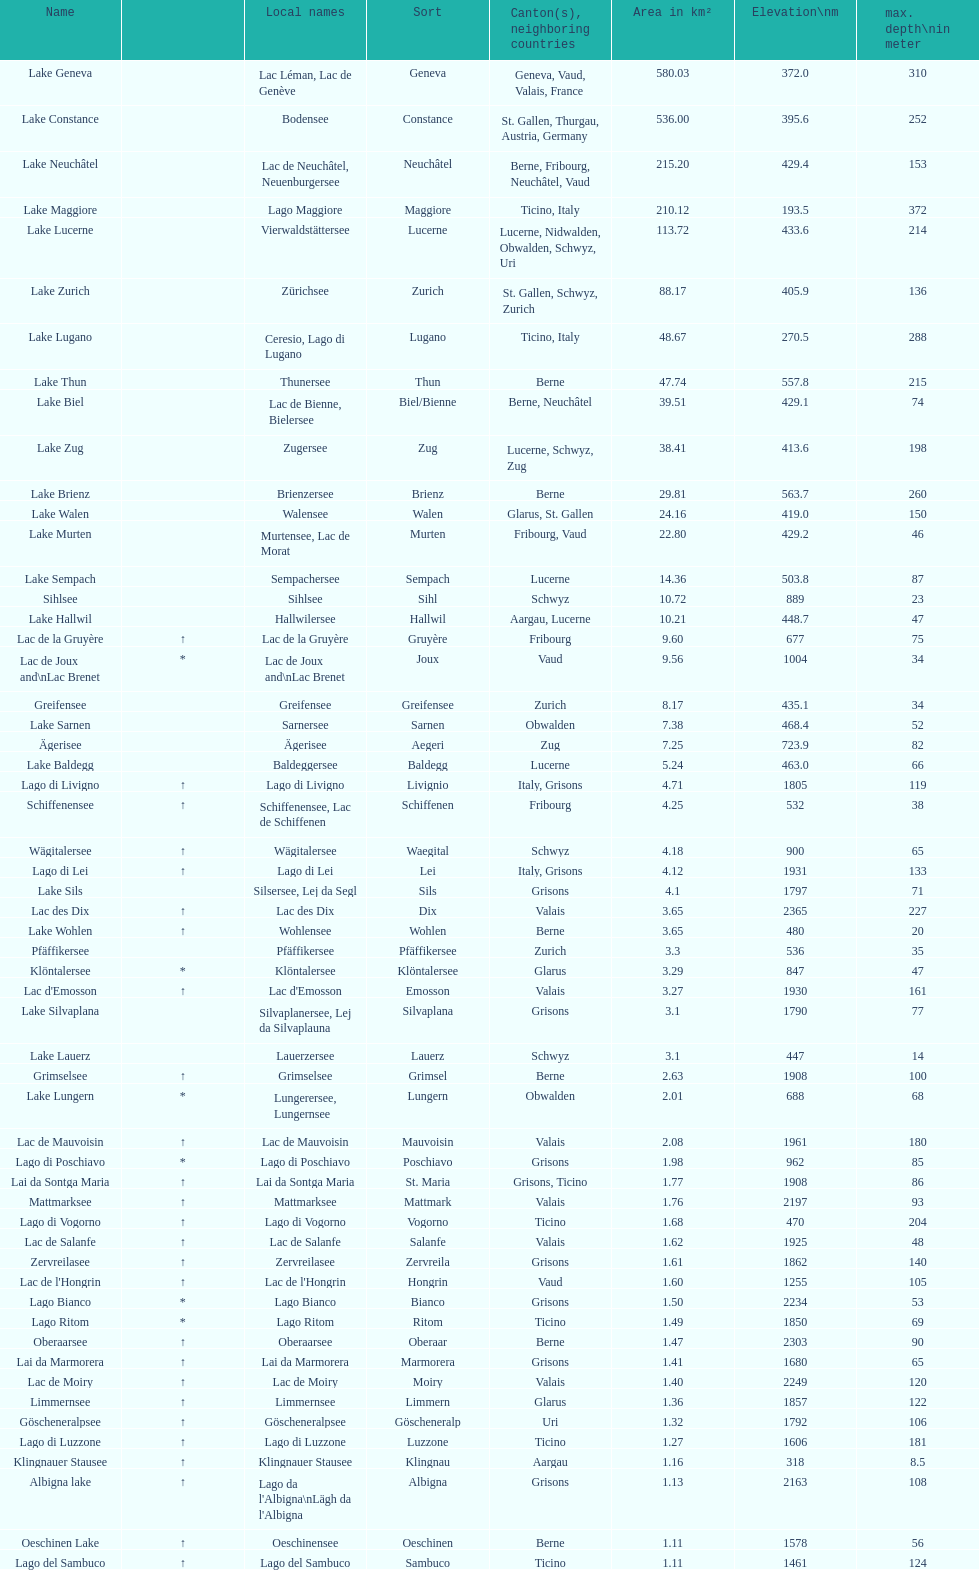I'm looking to parse the entire table for insights. Could you assist me with that? {'header': ['Name', '', 'Local names', 'Sort', 'Canton(s), neighboring countries', 'Area in km²', 'Elevation\\nm', 'max. depth\\nin meter'], 'rows': [['Lake Geneva', '', 'Lac Léman, Lac de Genève', 'Geneva', 'Geneva, Vaud, Valais, France', '580.03', '372.0', '310'], ['Lake Constance', '', 'Bodensee', 'Constance', 'St. Gallen, Thurgau, Austria, Germany', '536.00', '395.6', '252'], ['Lake Neuchâtel', '', 'Lac de Neuchâtel, Neuenburgersee', 'Neuchâtel', 'Berne, Fribourg, Neuchâtel, Vaud', '215.20', '429.4', '153'], ['Lake Maggiore', '', 'Lago Maggiore', 'Maggiore', 'Ticino, Italy', '210.12', '193.5', '372'], ['Lake Lucerne', '', 'Vierwaldstättersee', 'Lucerne', 'Lucerne, Nidwalden, Obwalden, Schwyz, Uri', '113.72', '433.6', '214'], ['Lake Zurich', '', 'Zürichsee', 'Zurich', 'St. Gallen, Schwyz, Zurich', '88.17', '405.9', '136'], ['Lake Lugano', '', 'Ceresio, Lago di Lugano', 'Lugano', 'Ticino, Italy', '48.67', '270.5', '288'], ['Lake Thun', '', 'Thunersee', 'Thun', 'Berne', '47.74', '557.8', '215'], ['Lake Biel', '', 'Lac de Bienne, Bielersee', 'Biel/Bienne', 'Berne, Neuchâtel', '39.51', '429.1', '74'], ['Lake Zug', '', 'Zugersee', 'Zug', 'Lucerne, Schwyz, Zug', '38.41', '413.6', '198'], ['Lake Brienz', '', 'Brienzersee', 'Brienz', 'Berne', '29.81', '563.7', '260'], ['Lake Walen', '', 'Walensee', 'Walen', 'Glarus, St. Gallen', '24.16', '419.0', '150'], ['Lake Murten', '', 'Murtensee, Lac de Morat', 'Murten', 'Fribourg, Vaud', '22.80', '429.2', '46'], ['Lake Sempach', '', 'Sempachersee', 'Sempach', 'Lucerne', '14.36', '503.8', '87'], ['Sihlsee', '', 'Sihlsee', 'Sihl', 'Schwyz', '10.72', '889', '23'], ['Lake Hallwil', '', 'Hallwilersee', 'Hallwil', 'Aargau, Lucerne', '10.21', '448.7', '47'], ['Lac de la Gruyère', '↑', 'Lac de la Gruyère', 'Gruyère', 'Fribourg', '9.60', '677', '75'], ['Lac de Joux and\\nLac Brenet', '*', 'Lac de Joux and\\nLac Brenet', 'Joux', 'Vaud', '9.56', '1004', '34'], ['Greifensee', '', 'Greifensee', 'Greifensee', 'Zurich', '8.17', '435.1', '34'], ['Lake Sarnen', '', 'Sarnersee', 'Sarnen', 'Obwalden', '7.38', '468.4', '52'], ['Ägerisee', '', 'Ägerisee', 'Aegeri', 'Zug', '7.25', '723.9', '82'], ['Lake Baldegg', '', 'Baldeggersee', 'Baldegg', 'Lucerne', '5.24', '463.0', '66'], ['Lago di Livigno', '↑', 'Lago di Livigno', 'Livignio', 'Italy, Grisons', '4.71', '1805', '119'], ['Schiffenensee', '↑', 'Schiffenensee, Lac de Schiffenen', 'Schiffenen', 'Fribourg', '4.25', '532', '38'], ['Wägitalersee', '↑', 'Wägitalersee', 'Waegital', 'Schwyz', '4.18', '900', '65'], ['Lago di Lei', '↑', 'Lago di Lei', 'Lei', 'Italy, Grisons', '4.12', '1931', '133'], ['Lake Sils', '', 'Silsersee, Lej da Segl', 'Sils', 'Grisons', '4.1', '1797', '71'], ['Lac des Dix', '↑', 'Lac des Dix', 'Dix', 'Valais', '3.65', '2365', '227'], ['Lake Wohlen', '↑', 'Wohlensee', 'Wohlen', 'Berne', '3.65', '480', '20'], ['Pfäffikersee', '', 'Pfäffikersee', 'Pfäffikersee', 'Zurich', '3.3', '536', '35'], ['Klöntalersee', '*', 'Klöntalersee', 'Klöntalersee', 'Glarus', '3.29', '847', '47'], ["Lac d'Emosson", '↑', "Lac d'Emosson", 'Emosson', 'Valais', '3.27', '1930', '161'], ['Lake Silvaplana', '', 'Silvaplanersee, Lej da Silvaplauna', 'Silvaplana', 'Grisons', '3.1', '1790', '77'], ['Lake Lauerz', '', 'Lauerzersee', 'Lauerz', 'Schwyz', '3.1', '447', '14'], ['Grimselsee', '↑', 'Grimselsee', 'Grimsel', 'Berne', '2.63', '1908', '100'], ['Lake Lungern', '*', 'Lungerersee, Lungernsee', 'Lungern', 'Obwalden', '2.01', '688', '68'], ['Lac de Mauvoisin', '↑', 'Lac de Mauvoisin', 'Mauvoisin', 'Valais', '2.08', '1961', '180'], ['Lago di Poschiavo', '*', 'Lago di Poschiavo', 'Poschiavo', 'Grisons', '1.98', '962', '85'], ['Lai da Sontga Maria', '↑', 'Lai da Sontga Maria', 'St. Maria', 'Grisons, Ticino', '1.77', '1908', '86'], ['Mattmarksee', '↑', 'Mattmarksee', 'Mattmark', 'Valais', '1.76', '2197', '93'], ['Lago di Vogorno', '↑', 'Lago di Vogorno', 'Vogorno', 'Ticino', '1.68', '470', '204'], ['Lac de Salanfe', '↑', 'Lac de Salanfe', 'Salanfe', 'Valais', '1.62', '1925', '48'], ['Zervreilasee', '↑', 'Zervreilasee', 'Zervreila', 'Grisons', '1.61', '1862', '140'], ["Lac de l'Hongrin", '↑', "Lac de l'Hongrin", 'Hongrin', 'Vaud', '1.60', '1255', '105'], ['Lago Bianco', '*', 'Lago Bianco', 'Bianco', 'Grisons', '1.50', '2234', '53'], ['Lago Ritom', '*', 'Lago Ritom', 'Ritom', 'Ticino', '1.49', '1850', '69'], ['Oberaarsee', '↑', 'Oberaarsee', 'Oberaar', 'Berne', '1.47', '2303', '90'], ['Lai da Marmorera', '↑', 'Lai da Marmorera', 'Marmorera', 'Grisons', '1.41', '1680', '65'], ['Lac de Moiry', '↑', 'Lac de Moiry', 'Moiry', 'Valais', '1.40', '2249', '120'], ['Limmernsee', '↑', 'Limmernsee', 'Limmern', 'Glarus', '1.36', '1857', '122'], ['Göscheneralpsee', '↑', 'Göscheneralpsee', 'Göscheneralp', 'Uri', '1.32', '1792', '106'], ['Lago di Luzzone', '↑', 'Lago di Luzzone', 'Luzzone', 'Ticino', '1.27', '1606', '181'], ['Klingnauer Stausee', '↑', 'Klingnauer Stausee', 'Klingnau', 'Aargau', '1.16', '318', '8.5'], ['Albigna lake', '↑', "Lago da l'Albigna\\nLägh da l'Albigna", 'Albigna', 'Grisons', '1.13', '2163', '108'], ['Oeschinen Lake', '↑', 'Oeschinensee', 'Oeschinen', 'Berne', '1.11', '1578', '56'], ['Lago del Sambuco', '↑', 'Lago del Sambuco', 'Sambuco', 'Ticino', '1.11', '1461', '124']]} Name the largest lake Lake Geneva. 